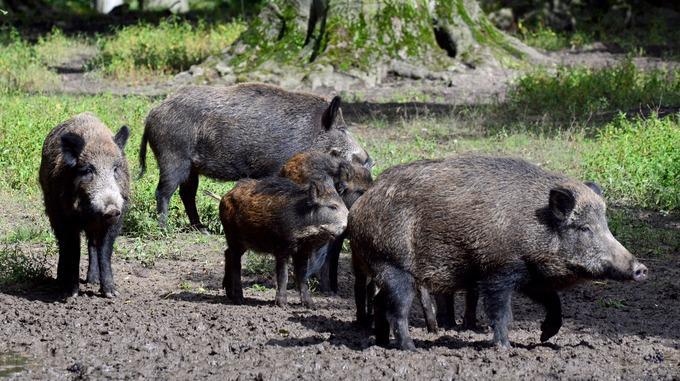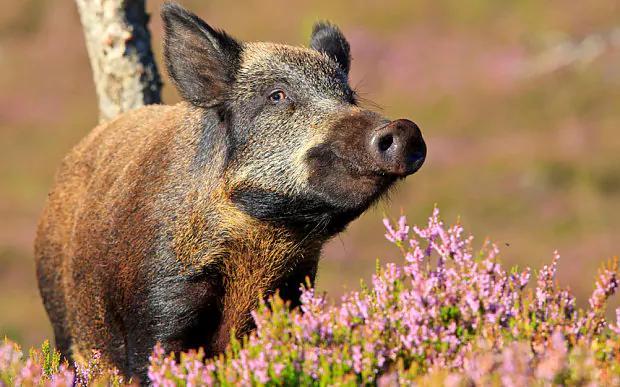The first image is the image on the left, the second image is the image on the right. Assess this claim about the two images: "There is a single boar in the left image.". Correct or not? Answer yes or no. No. 